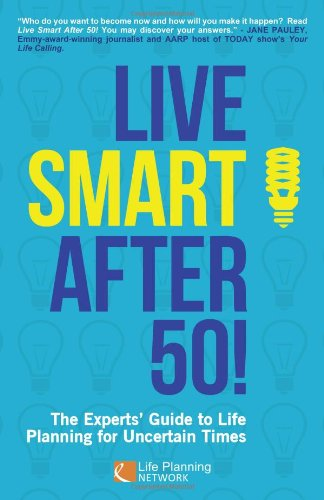Is this a romantic book? No, 'Live Smart After 50!' is not a romantic book. It's aimed at providing advice and strategies for personal growth and life planning. 